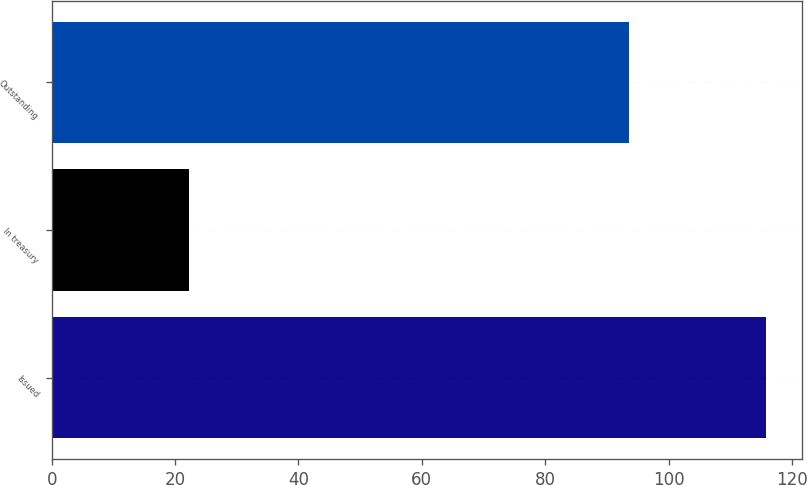<chart> <loc_0><loc_0><loc_500><loc_500><bar_chart><fcel>Issued<fcel>In treasury<fcel>Outstanding<nl><fcel>115.8<fcel>22.3<fcel>93.5<nl></chart> 